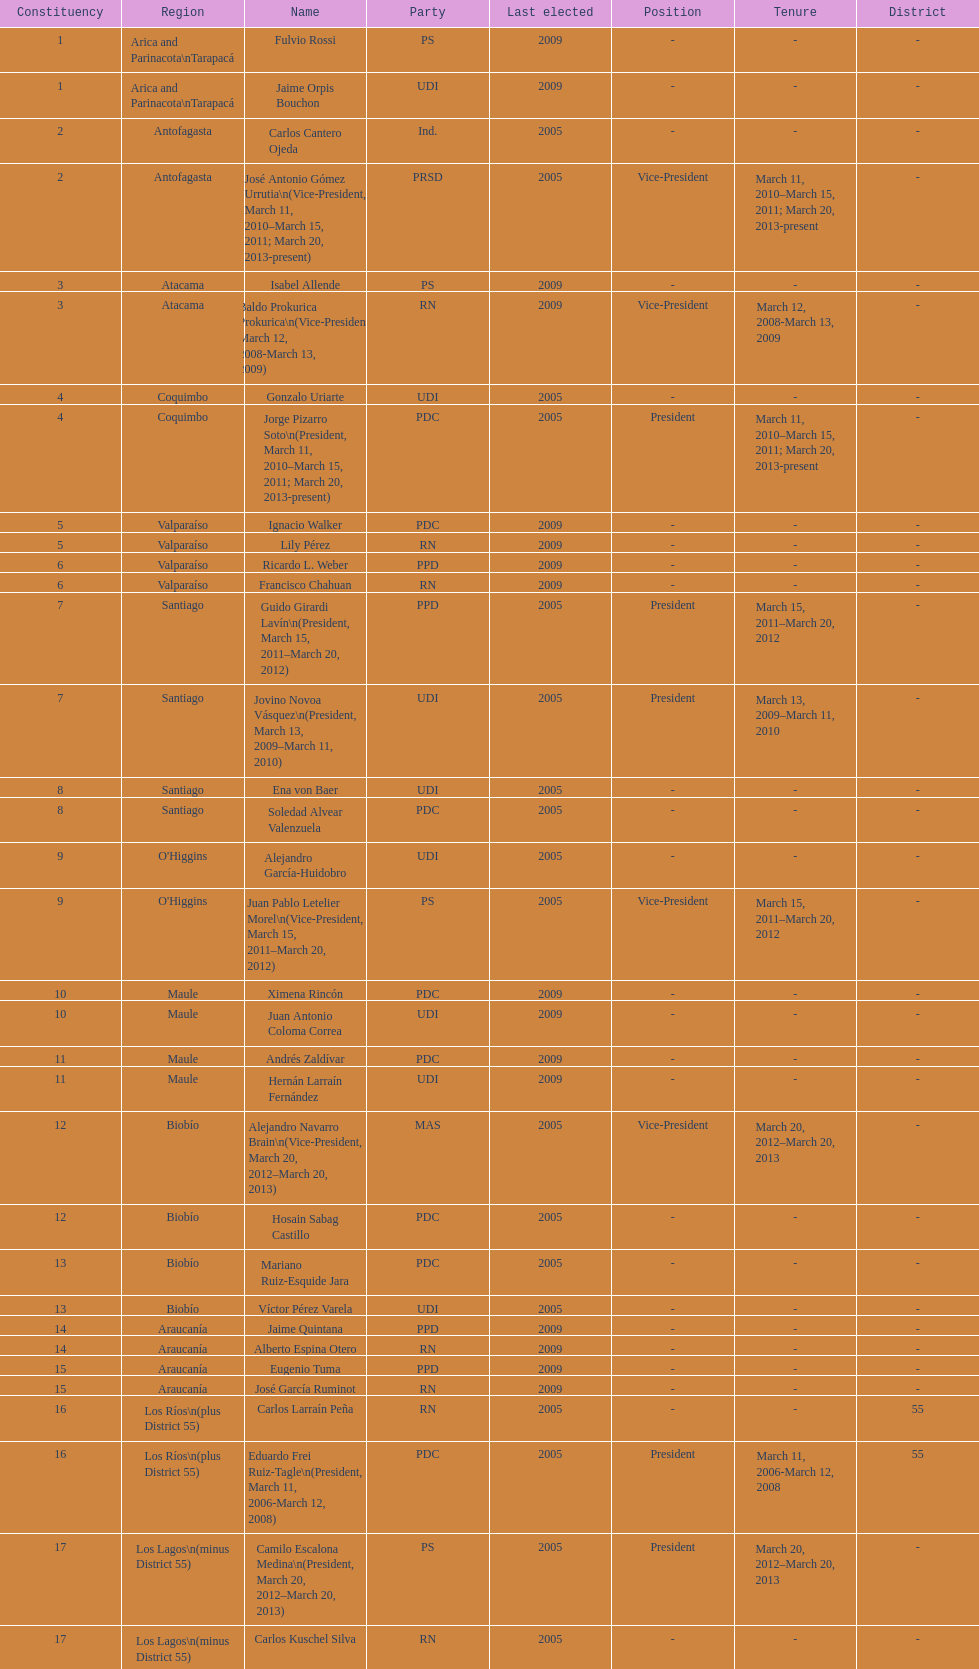How long was baldo prokurica prokurica vice-president? 1 year. 